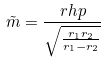Convert formula to latex. <formula><loc_0><loc_0><loc_500><loc_500>\tilde { m } = \frac { r h p } { \sqrt { \frac { r _ { 1 } r _ { 2 } } { r _ { 1 } - r _ { 2 } } } }</formula> 